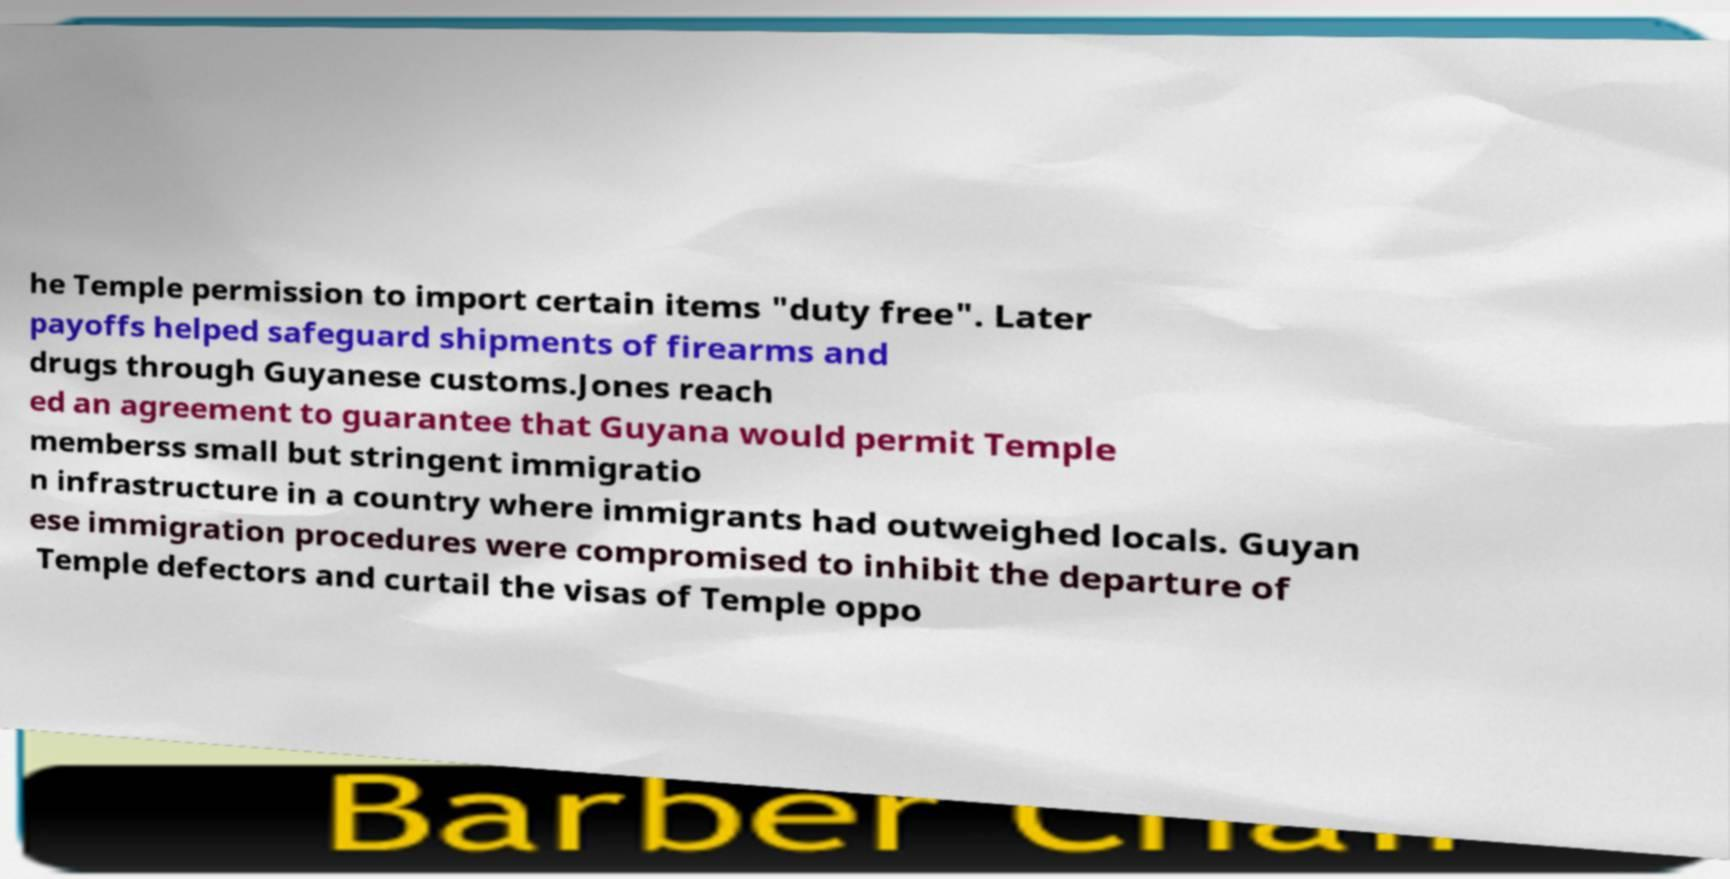Can you accurately transcribe the text from the provided image for me? he Temple permission to import certain items "duty free". Later payoffs helped safeguard shipments of firearms and drugs through Guyanese customs.Jones reach ed an agreement to guarantee that Guyana would permit Temple memberss small but stringent immigratio n infrastructure in a country where immigrants had outweighed locals. Guyan ese immigration procedures were compromised to inhibit the departure of Temple defectors and curtail the visas of Temple oppo 